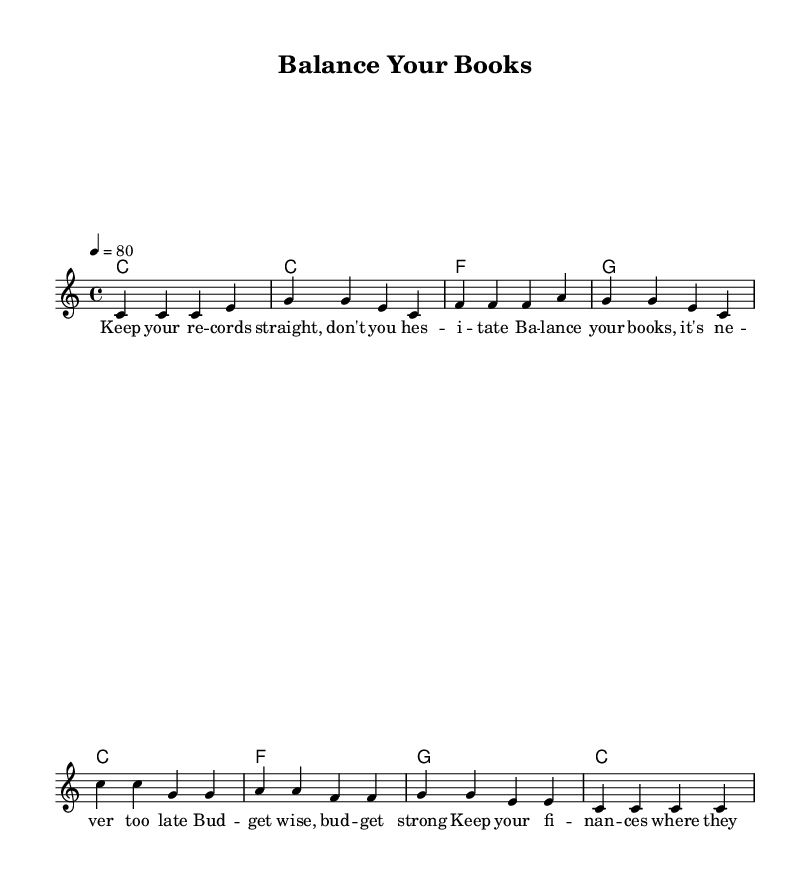What is the key signature of this music? The key signature is C major, which has no sharps or flats.
Answer: C major What is the time signature of this music? The time signature is indicated at the beginning of the score and is 4/4, meaning there are four beats in each measure.
Answer: 4/4 What is the tempo for this song? The tempo is marked at 4 beats per minute which is indicated in the score as a tempo marking.
Answer: 80 How many measures are in the verse section? The verse section consists of four measures, as seen in the notation where distinct measures are counted.
Answer: 4 Which chord appears the most frequently in the harmonies? The C chord appears the most frequently in the harmonic section, as it is presented in multiple measures.
Answer: C What is the chorus line structure? The chorus consists of two phrases with a repetitive pattern that emphasizes budgeting, structured in a six-line format.
Answer: Six lines What thematic element is emphasized in the lyrics? The lyrics emphasize financial responsibility and budgeting, underscoring the importance of managing finances wisely.
Answer: Financial responsibility 